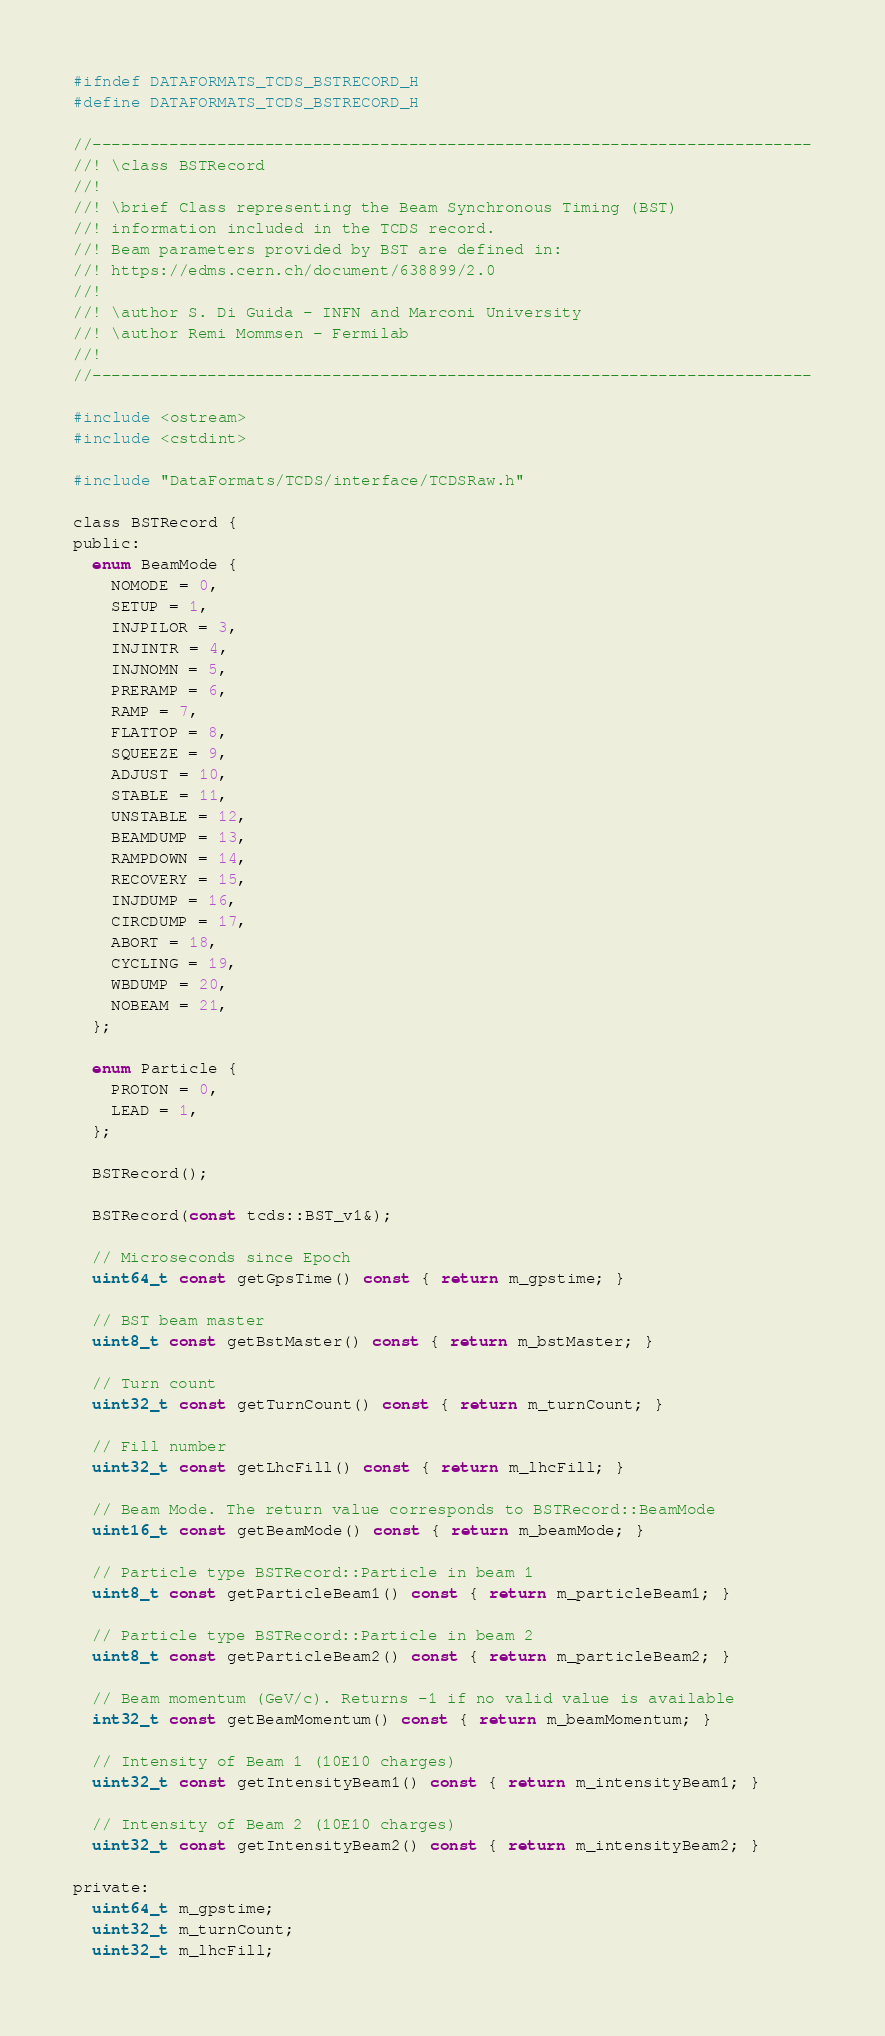<code> <loc_0><loc_0><loc_500><loc_500><_C_>#ifndef DATAFORMATS_TCDS_BSTRECORD_H
#define DATAFORMATS_TCDS_BSTRECORD_H

//---------------------------------------------------------------------------
//! \class BSTRecord
//!
//! \brief Class representing the Beam Synchronous Timing (BST)
//! information included in the TCDS record.
//! Beam parameters provided by BST are defined in:
//! https://edms.cern.ch/document/638899/2.0
//!
//! \author S. Di Guida - INFN and Marconi University
//! \author Remi Mommsen - Fermilab
//!
//---------------------------------------------------------------------------

#include <ostream>
#include <cstdint>

#include "DataFormats/TCDS/interface/TCDSRaw.h"

class BSTRecord {
public:
  enum BeamMode {
    NOMODE = 0,
    SETUP = 1,
    INJPILOR = 3,
    INJINTR = 4,
    INJNOMN = 5,
    PRERAMP = 6,
    RAMP = 7,
    FLATTOP = 8,
    SQUEEZE = 9,
    ADJUST = 10,
    STABLE = 11,
    UNSTABLE = 12,
    BEAMDUMP = 13,
    RAMPDOWN = 14,
    RECOVERY = 15,
    INJDUMP = 16,
    CIRCDUMP = 17,
    ABORT = 18,
    CYCLING = 19,
    WBDUMP = 20,
    NOBEAM = 21,
  };

  enum Particle {
    PROTON = 0,
    LEAD = 1,
  };

  BSTRecord();

  BSTRecord(const tcds::BST_v1&);

  // Microseconds since Epoch
  uint64_t const getGpsTime() const { return m_gpstime; }

  // BST beam master
  uint8_t const getBstMaster() const { return m_bstMaster; }

  // Turn count
  uint32_t const getTurnCount() const { return m_turnCount; }

  // Fill number
  uint32_t const getLhcFill() const { return m_lhcFill; }

  // Beam Mode. The return value corresponds to BSTRecord::BeamMode
  uint16_t const getBeamMode() const { return m_beamMode; }

  // Particle type BSTRecord::Particle in beam 1
  uint8_t const getParticleBeam1() const { return m_particleBeam1; }

  // Particle type BSTRecord::Particle in beam 2
  uint8_t const getParticleBeam2() const { return m_particleBeam2; }

  // Beam momentum (GeV/c). Returns -1 if no valid value is available
  int32_t const getBeamMomentum() const { return m_beamMomentum; }

  // Intensity of Beam 1 (10E10 charges)
  uint32_t const getIntensityBeam1() const { return m_intensityBeam1; }

  // Intensity of Beam 2 (10E10 charges)
  uint32_t const getIntensityBeam2() const { return m_intensityBeam2; }

private:
  uint64_t m_gpstime;
  uint32_t m_turnCount;
  uint32_t m_lhcFill;</code> 